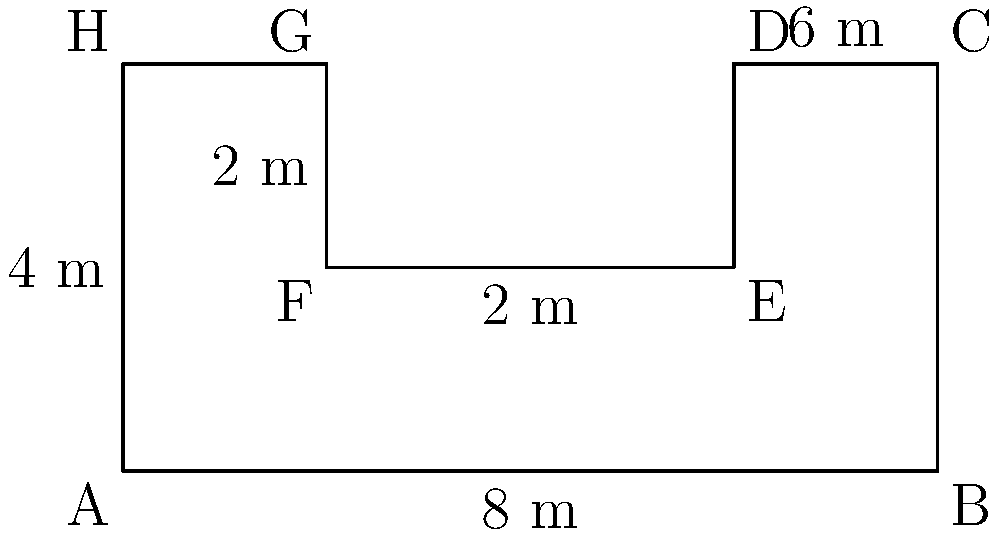You're designing a custom-shaped platform for your classic car display at an upcoming show. The platform has a unique L-shape, as shown in the diagram. If the total length is 8 meters and the maximum width is 4 meters, what is the area of the platform in square meters? Let's break this down step-by-step:

1) The platform can be divided into two rectangles:
   - A larger rectangle (ABCGH)
   - A smaller rectangle (DEFG)

2) For the larger rectangle (ABCGH):
   - Length = 8 m
   - Width = 4 m
   - Area = $8 \times 4 = 32$ m²

3) For the smaller rectangle (DEFG):
   - Length = 2 m (8 m - 6 m)
   - Width = 2 m
   - Area = $2 \times 2 = 4$ m²

4) The area of the L-shaped platform is the area of the larger rectangle minus the area of the smaller rectangle:

   $\text{Total Area} = \text{Area of ABCGH} - \text{Area of DEFG}$
   $\text{Total Area} = 32 \text{ m}^2 - 4 \text{ m}^2 = 28 \text{ m}^2$

Therefore, the area of the custom-shaped car show display platform is 28 square meters.
Answer: 28 m² 